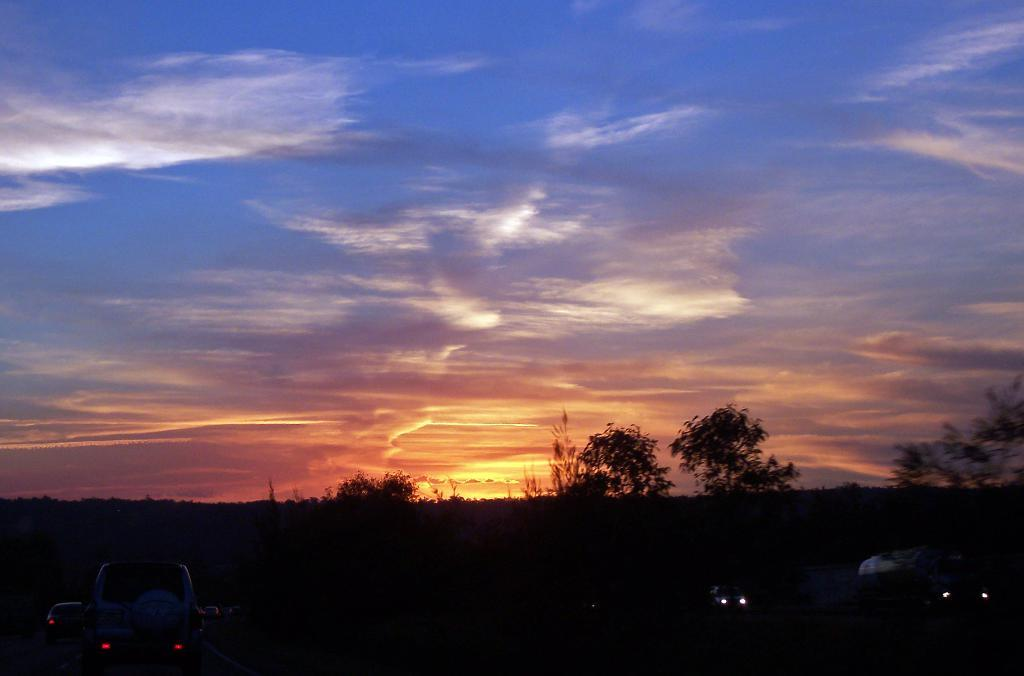What types of vehicles can be seen in the image? There are vehicles in the image, but the specific types are not mentioned. What else is present in the image besides vehicles? There are trees, a road, and other objects in the image. Can you describe the natural elements in the image? There are trees and the sky is visible at the top of the image. Where are the grapes placed in the image? There are no grapes present in the image. What type of toy can be seen in the image? There is no toy present in the image. 